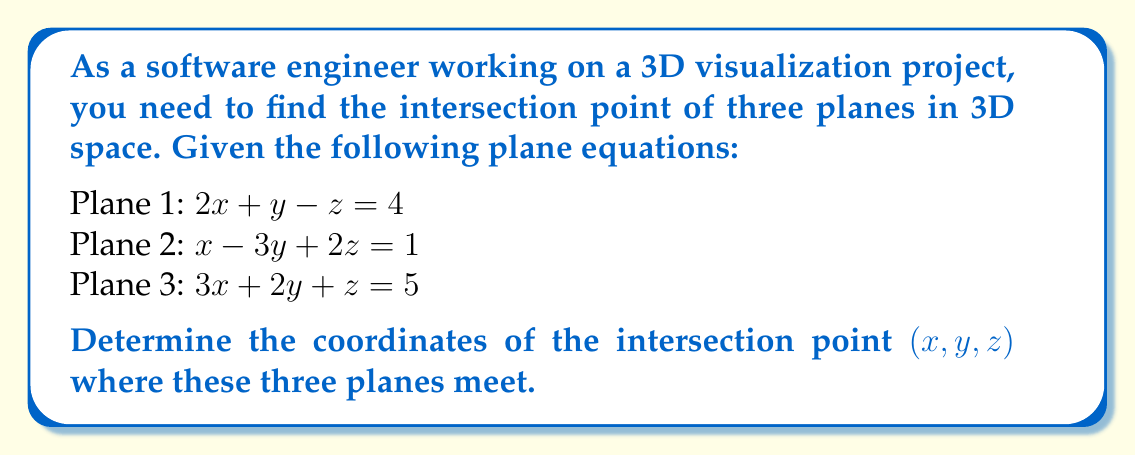Provide a solution to this math problem. To find the intersection point of three planes, we need to solve the system of linear equations formed by the plane equations. We can use the following steps:

1. Write the system of equations:
   $$\begin{cases}
   2x + y - z = 4 \\
   x - 3y + 2z = 1 \\
   3x + 2y + z = 5
   \end{cases}$$

2. We can solve this system using elimination or substitution methods. Let's use elimination:

3. Multiply the first equation by 3 and the third equation by -2:
   $$\begin{cases}
   6x + 3y - 3z = 12 \\
   x - 3y + 2z = 1 \\
   -6x - 4y - 2z = -10
   \end{cases}$$

4. Add these equations to eliminate x:
   $$-y - 3z = 3$$

5. Now, multiply the second equation by 3 and add it to the first equation:
   $$5x - 8y + 5z = 7$$

6. We now have two equations with two unknowns:
   $$\begin{cases}
   -y - 3z = 3 \\
   5x - 8y + 5z = 7
   \end{cases}$$

7. From the first equation: $y = -3 - 3z$

8. Substitute this into the second equation:
   $$5x - 8(-3 - 3z) + 5z = 7$$
   $$5x + 24 + 24z + 5z = 7$$
   $$5x + 29z = -17$$

9. Now we have:
   $$\begin{cases}
   5x + 29z = -17 \\
   -y - 3z = 3
   \end{cases}$$

10. From the first equation: $x = \frac{-17 - 29z}{5}$

11. Substitute x and y into the original second equation:
    $$\frac{-17 - 29z}{5} - 3(-3 - 3z) + 2z = 1$$
    $$-17 - 29z + 15 + 45z + 10z = 5$$
    $$26z = 7$$
    $$z = \frac{7}{26}$$

12. Now we can find y:
    $$y = -3 - 3(\frac{7}{26}) = -3 - \frac{21}{26} = -\frac{99}{26}$$

13. And x:
    $$x = \frac{-17 - 29(\frac{7}{26})}{5} = \frac{-442 - 203}{130} = -\frac{645}{130} = -\frac{129}{26}$$

Therefore, the intersection point is $(-\frac{129}{26}, -\frac{99}{26}, \frac{7}{26})$.
Answer: The intersection point of the three planes is $(-\frac{129}{26}, -\frac{99}{26}, \frac{7}{26})$ or approximately $(-4.962, -3.808, 0.269)$. 